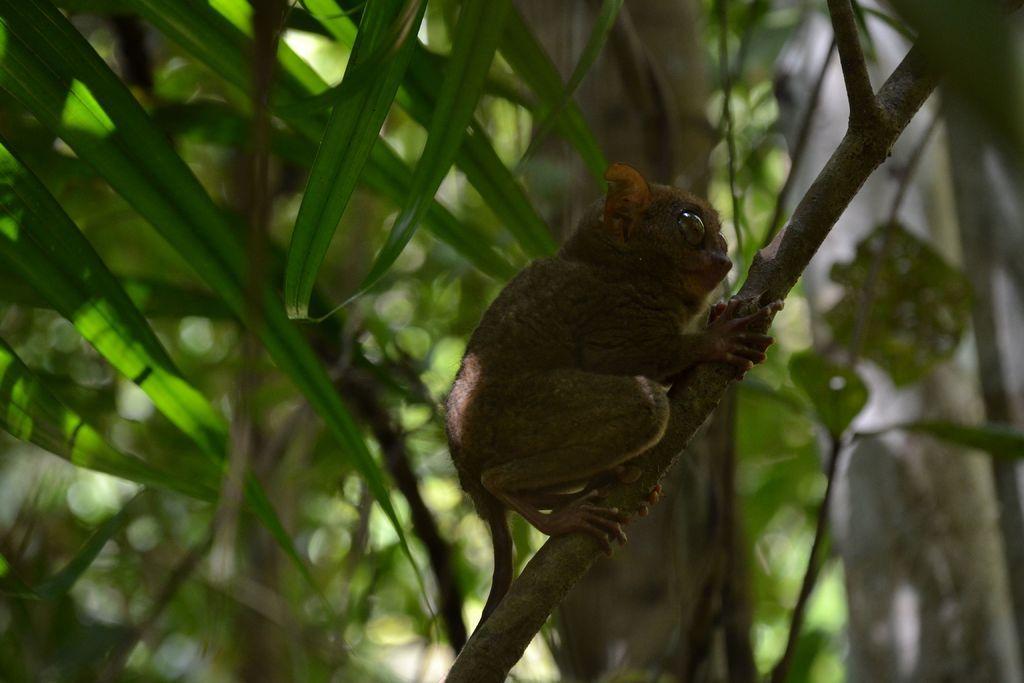In one or two sentences, can you explain what this image depicts? In this image we can see an animal on a branch of the tree and in the background, we can see some other trees. 